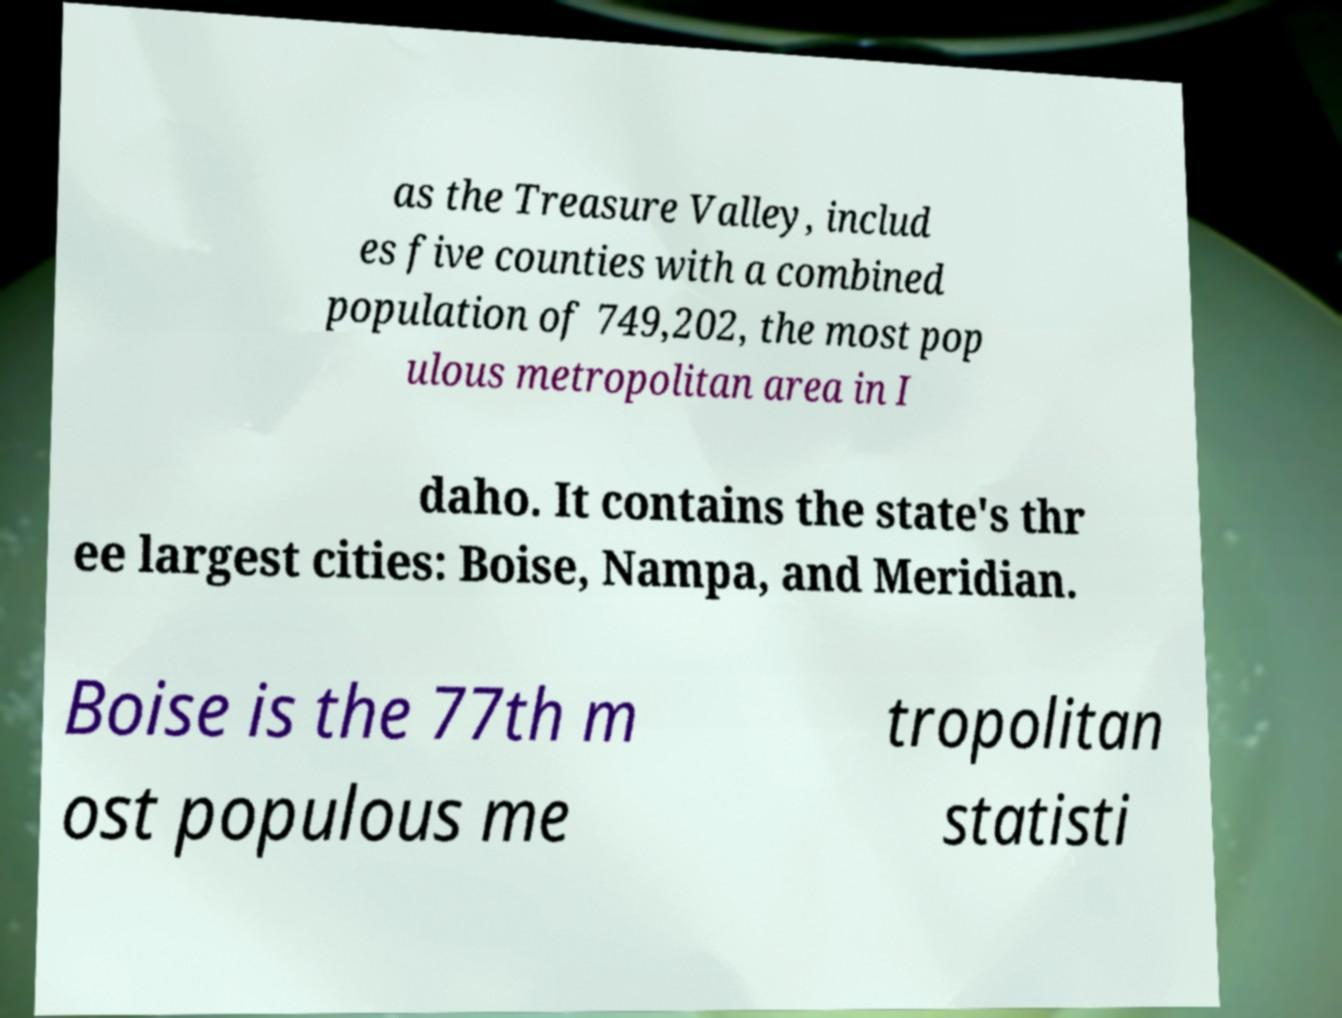Could you assist in decoding the text presented in this image and type it out clearly? as the Treasure Valley, includ es five counties with a combined population of 749,202, the most pop ulous metropolitan area in I daho. It contains the state's thr ee largest cities: Boise, Nampa, and Meridian. Boise is the 77th m ost populous me tropolitan statisti 